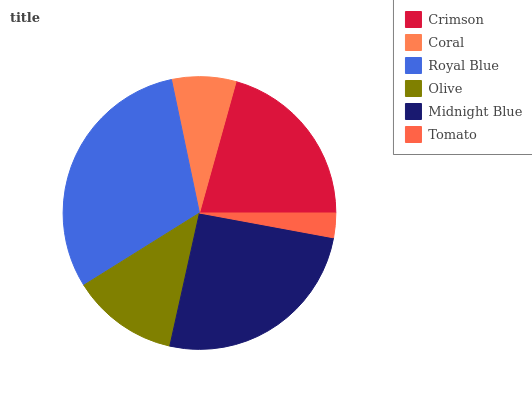Is Tomato the minimum?
Answer yes or no. Yes. Is Royal Blue the maximum?
Answer yes or no. Yes. Is Coral the minimum?
Answer yes or no. No. Is Coral the maximum?
Answer yes or no. No. Is Crimson greater than Coral?
Answer yes or no. Yes. Is Coral less than Crimson?
Answer yes or no. Yes. Is Coral greater than Crimson?
Answer yes or no. No. Is Crimson less than Coral?
Answer yes or no. No. Is Crimson the high median?
Answer yes or no. Yes. Is Olive the low median?
Answer yes or no. Yes. Is Royal Blue the high median?
Answer yes or no. No. Is Coral the low median?
Answer yes or no. No. 